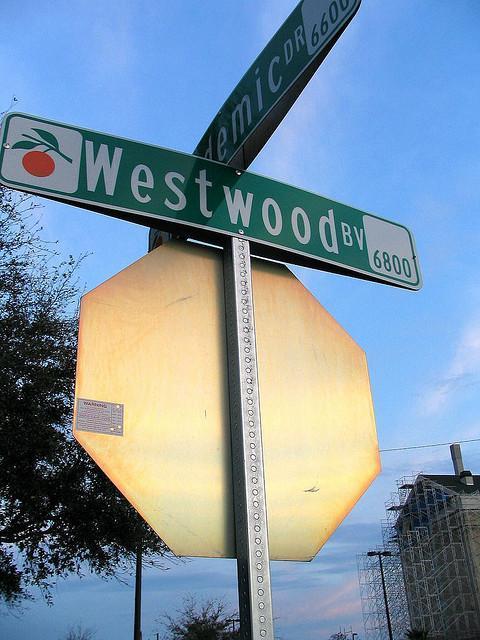How many brown horses are in the grass?
Give a very brief answer. 0. 